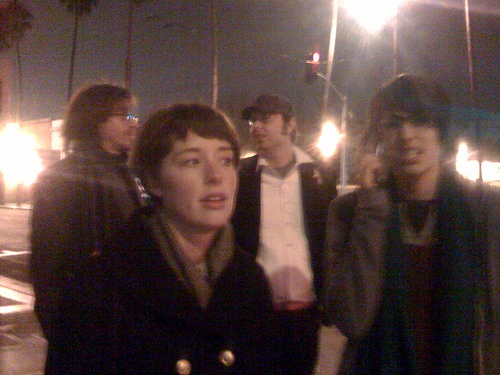<image>
Can you confirm if the girl is behind the boy? No. The girl is not behind the boy. From this viewpoint, the girl appears to be positioned elsewhere in the scene. 